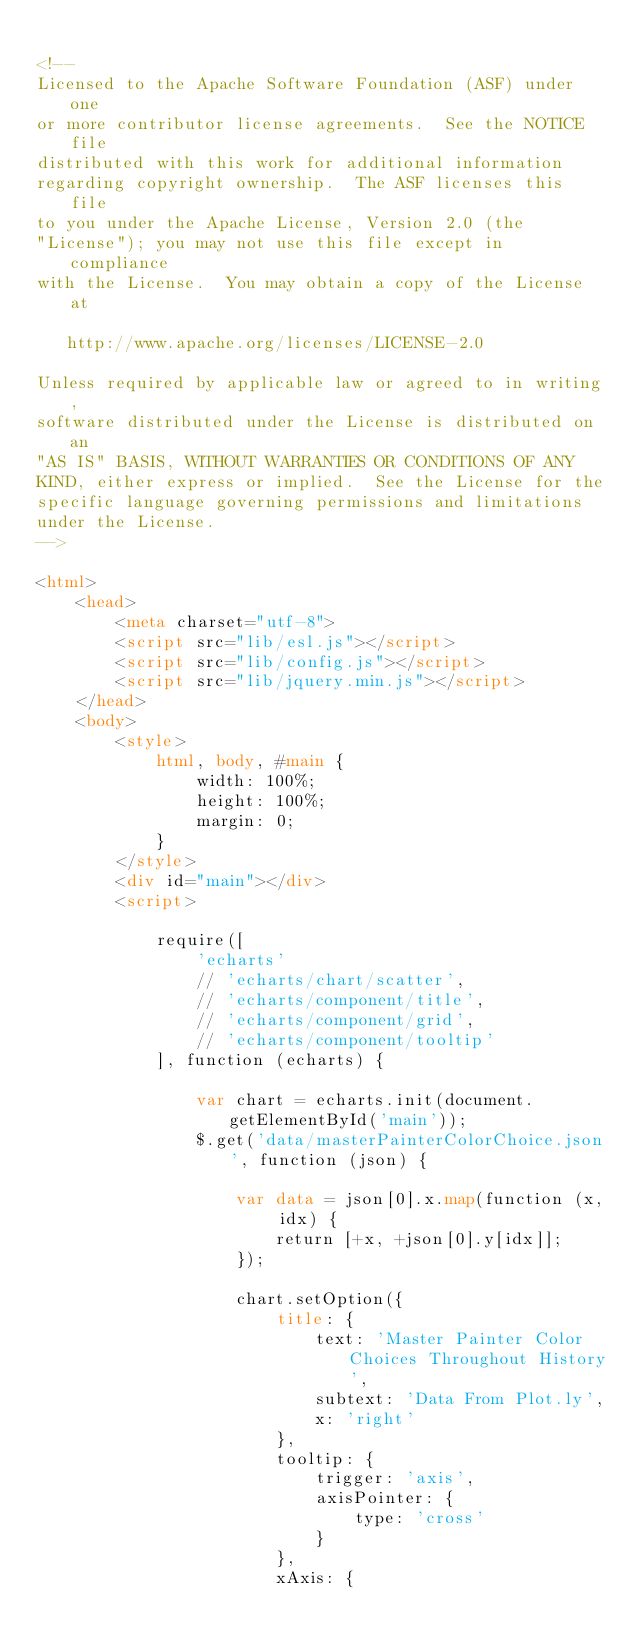Convert code to text. <code><loc_0><loc_0><loc_500><loc_500><_HTML_>
<!--
Licensed to the Apache Software Foundation (ASF) under one
or more contributor license agreements.  See the NOTICE file
distributed with this work for additional information
regarding copyright ownership.  The ASF licenses this file
to you under the Apache License, Version 2.0 (the
"License"); you may not use this file except in compliance
with the License.  You may obtain a copy of the License at

   http://www.apache.org/licenses/LICENSE-2.0

Unless required by applicable law or agreed to in writing,
software distributed under the License is distributed on an
"AS IS" BASIS, WITHOUT WARRANTIES OR CONDITIONS OF ANY
KIND, either express or implied.  See the License for the
specific language governing permissions and limitations
under the License.
-->

<html>
    <head>
        <meta charset="utf-8">
        <script src="lib/esl.js"></script>
        <script src="lib/config.js"></script>
        <script src="lib/jquery.min.js"></script>
    </head>
    <body>
        <style>
            html, body, #main {
                width: 100%;
                height: 100%;
                margin: 0;
            }
        </style>
        <div id="main"></div>
        <script>

            require([
                'echarts'
                // 'echarts/chart/scatter',
                // 'echarts/component/title',
                // 'echarts/component/grid',
                // 'echarts/component/tooltip'
            ], function (echarts) {

                var chart = echarts.init(document.getElementById('main'));
                $.get('data/masterPainterColorChoice.json', function (json) {

                    var data = json[0].x.map(function (x, idx) {
                        return [+x, +json[0].y[idx]];
                    });

                    chart.setOption({
                        title: {
                            text: 'Master Painter Color Choices Throughout History',
                            subtext: 'Data From Plot.ly',
                            x: 'right'
                        },
                        tooltip: {
                            trigger: 'axis',
                            axisPointer: {
                                type: 'cross'
                            }
                        },
                        xAxis: {</code> 